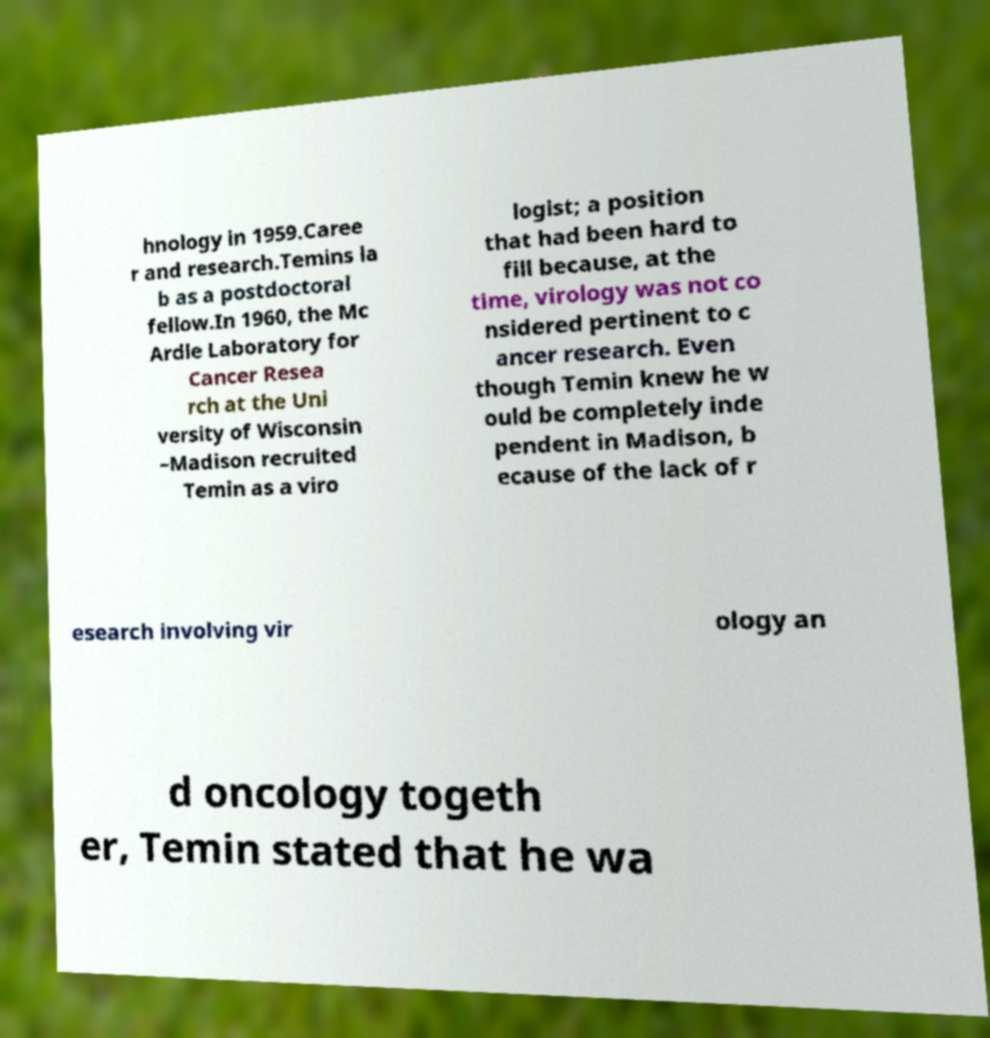Can you accurately transcribe the text from the provided image for me? hnology in 1959.Caree r and research.Temins la b as a postdoctoral fellow.In 1960, the Mc Ardle Laboratory for Cancer Resea rch at the Uni versity of Wisconsin –Madison recruited Temin as a viro logist; a position that had been hard to fill because, at the time, virology was not co nsidered pertinent to c ancer research. Even though Temin knew he w ould be completely inde pendent in Madison, b ecause of the lack of r esearch involving vir ology an d oncology togeth er, Temin stated that he wa 